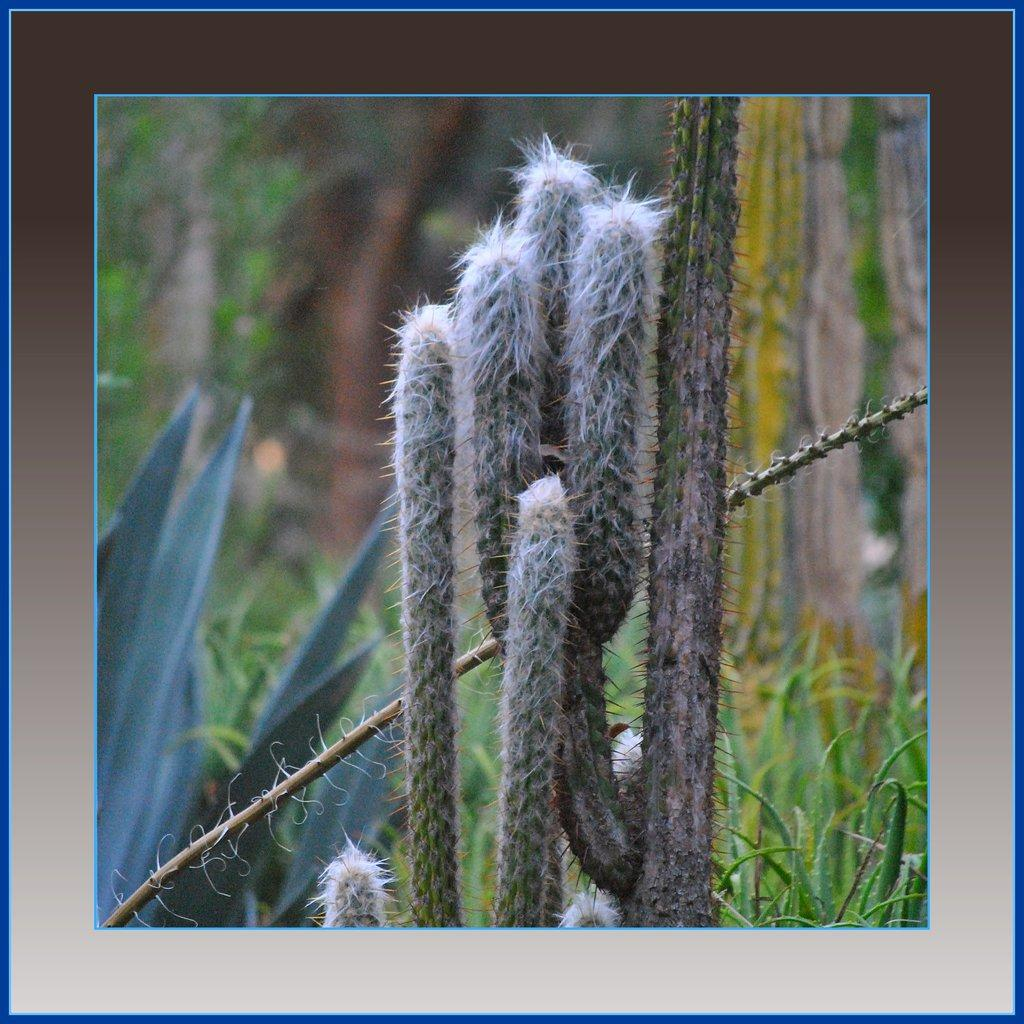What type of vegetation can be seen in the image? There are plants and trees in the image. Can you describe the setting of the image? The image appears to be a photo frame, which suggests that it is a still image of a natural scene. How many legs are visible in the image? There are no legs visible in the image, as it features plants and trees in a photo frame. What type of bed is shown in the image? There is no bed present in the image; it features plants and trees in a photo frame. 